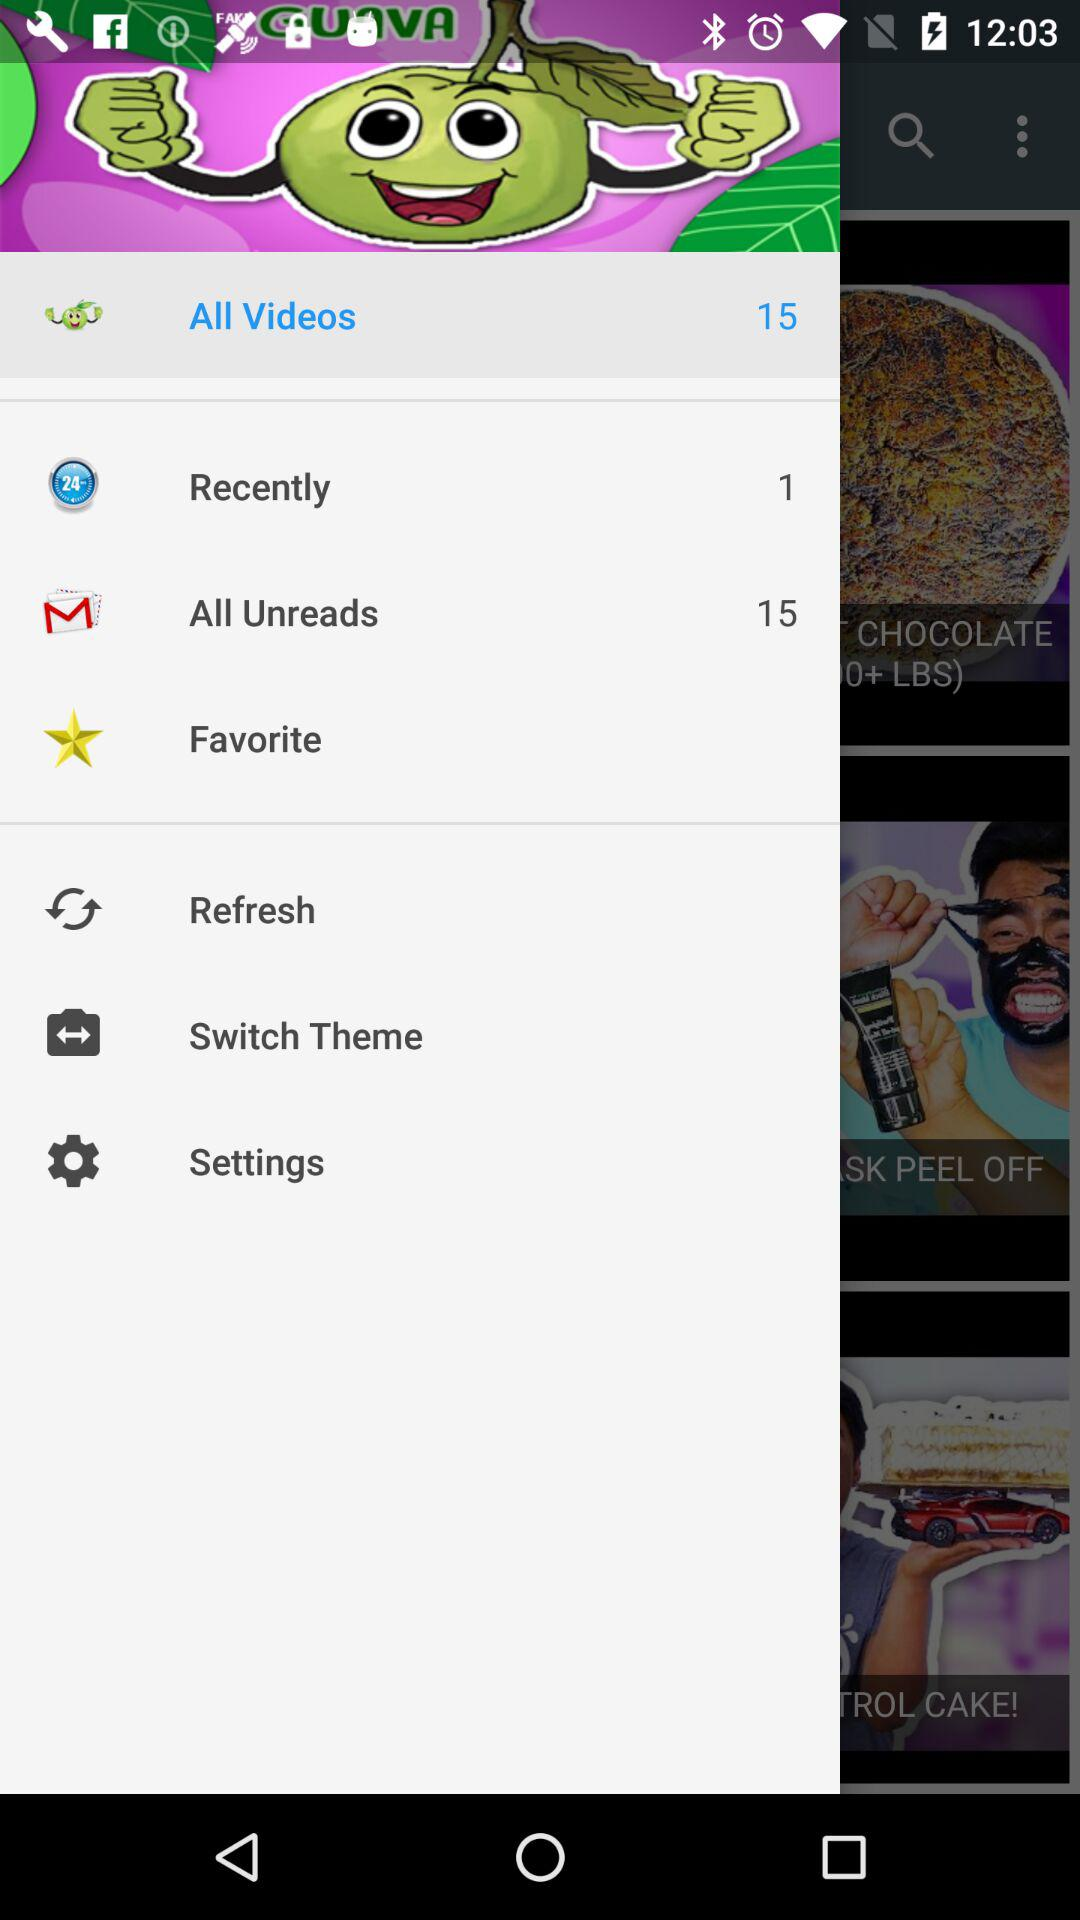What's the number of counts on "Recently"? The number of counts on "Recently" is 1. 